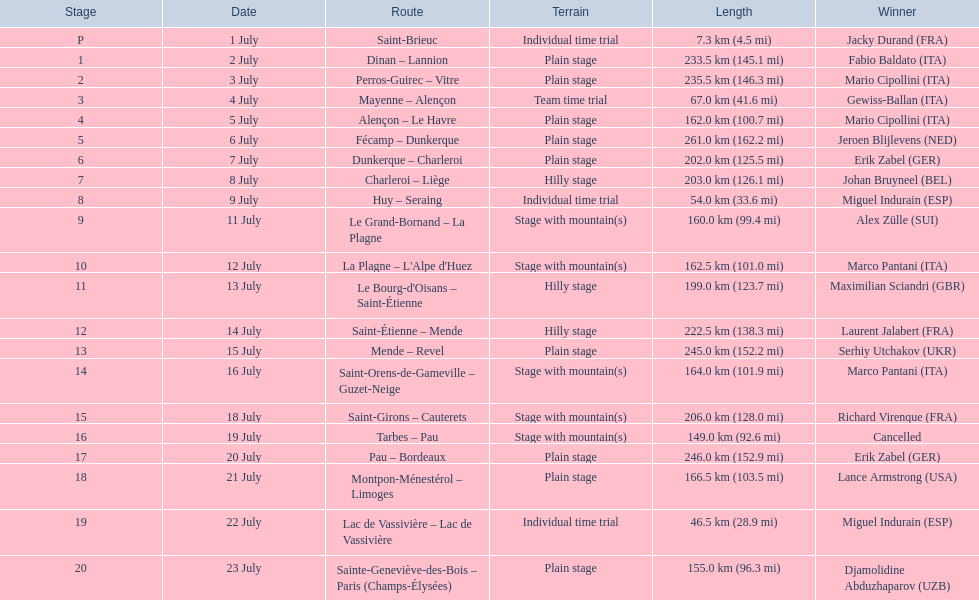When exactly did the 1995 tour de france occur? 1 July, 2 July, 3 July, 4 July, 5 July, 6 July, 7 July, 8 July, 9 July, 11 July, 12 July, 13 July, 14 July, 15 July, 16 July, 18 July, 19 July, 20 July, 21 July, 22 July, 23 July. What was the length of the race on july 8th? 203.0 km (126.1 mi). 